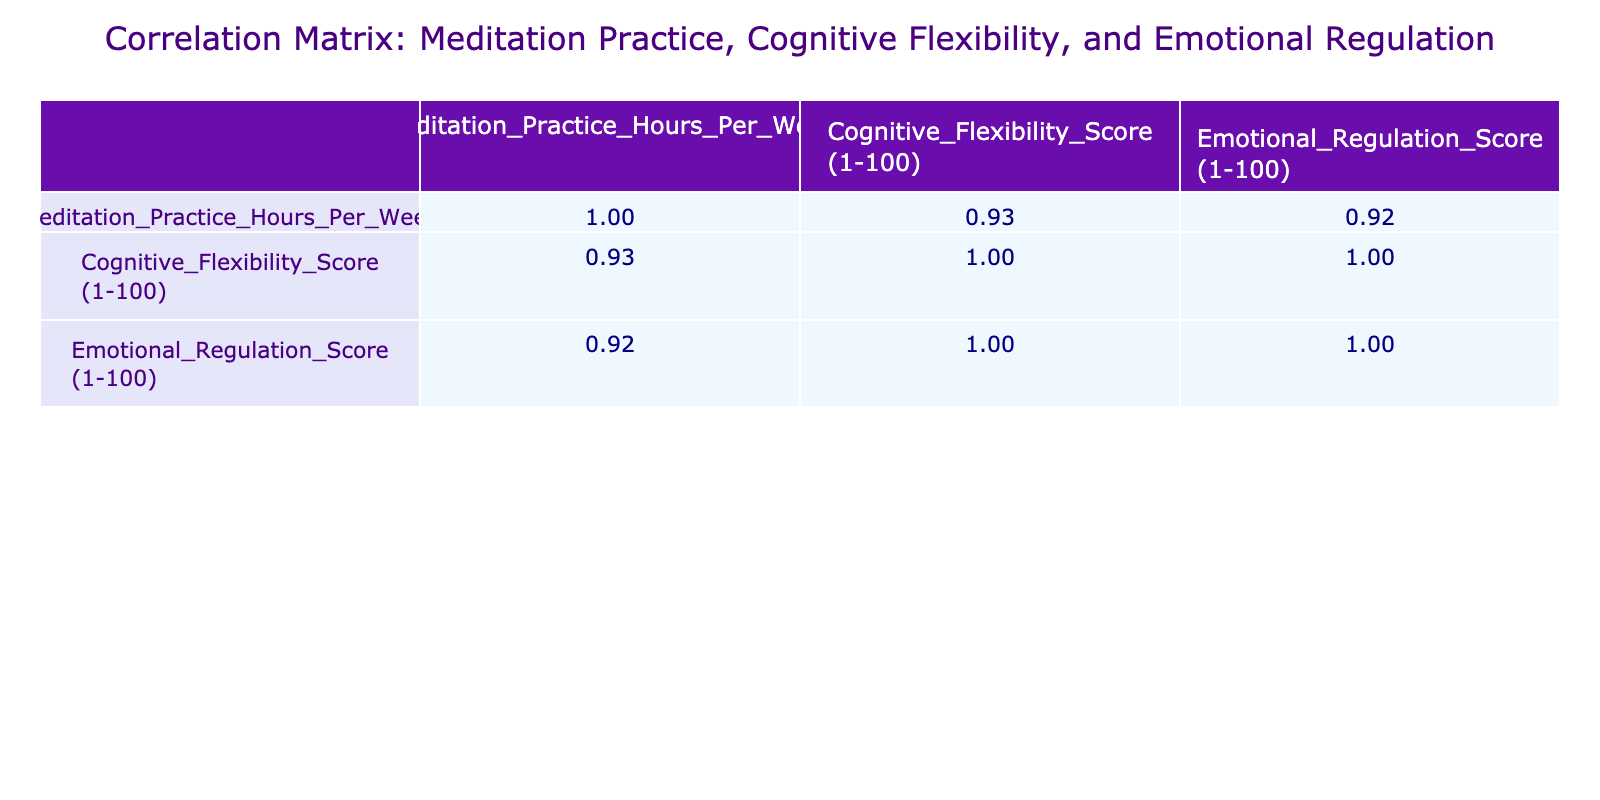What is the correlation between meditation practice hours per week and cognitive flexibility score? To find the correlation, we look at the correlation matrix, specifically the value at the intersection of "Meditation_Practice_Hours_Per_Week" and "Cognitive_Flexibility_Score (1-100)." From the matrix, we see that the value is 0.85.
Answer: 0.85 What is the average cognitive flexibility score for participants who meditate more than 5 hours per week? First, we filter participants who meditate more than 5 hours (participants 2, 4, 6, 9, 12, 13, and 14). Their cognitive flexibility scores are (85, 90, 88, 93, 87, 84, 91). We then sum these scores: 85 + 90 + 88 + 93 + 87 + 84 + 91 = 518. There are 7 participants, so the average is 518/7 = 74.
Answer: 74 Is there a participant who has both the highest meditation practice hours and the highest cognitive flexibility score? We examine the highest values for each criterion. The highest number of meditation hours is 15 (Participant 9) and the highest cognitive flexibility score is 93 (Participant 9). Because both values belong to the same participant, the answer is yes.
Answer: Yes What is the difference between the highest emotional regulation score and the lowest emotional regulation score among the participants? From the emotional regulation scores listed, the highest score is 95 (Participant 9) and the lowest score is 65 (Participant 7). To find the difference, we calculate: 95 - 65 = 30.
Answer: 30 How many participants scored above 85 in both cognitive flexibility and emotional regulation? We look for the participants whose scores in both cognitive flexibility and emotional regulation are greater than 85. Participants who meet this criteria are 2, 4, 6, 9, 12, and 14. There are 6 such participants.
Answer: 6 What is the correlation between cognitive flexibility and emotional regulation scores? In the correlation matrix, we check the intersection of "Cognitive_Flexibility_Score (1-100)" and "Emotional_Regulation_Score (1-100)." The correlation value is noted to be 0.93.
Answer: 0.93 Which participant has the lowest cognitive flexibility score and what is that score? We identify the lowest cognitive flexibility score by scanning the cognitive flexibility scores. The lowest score is 62, which belongs to Participant 10.
Answer: 62 Is there a participant who meditates 0 hours per week? By reviewing the "Meditation_Practice_Hours_Per_Week" column, we see that Participant 7 has a score of 0 hours. Thus, the answer is yes.
Answer: Yes 